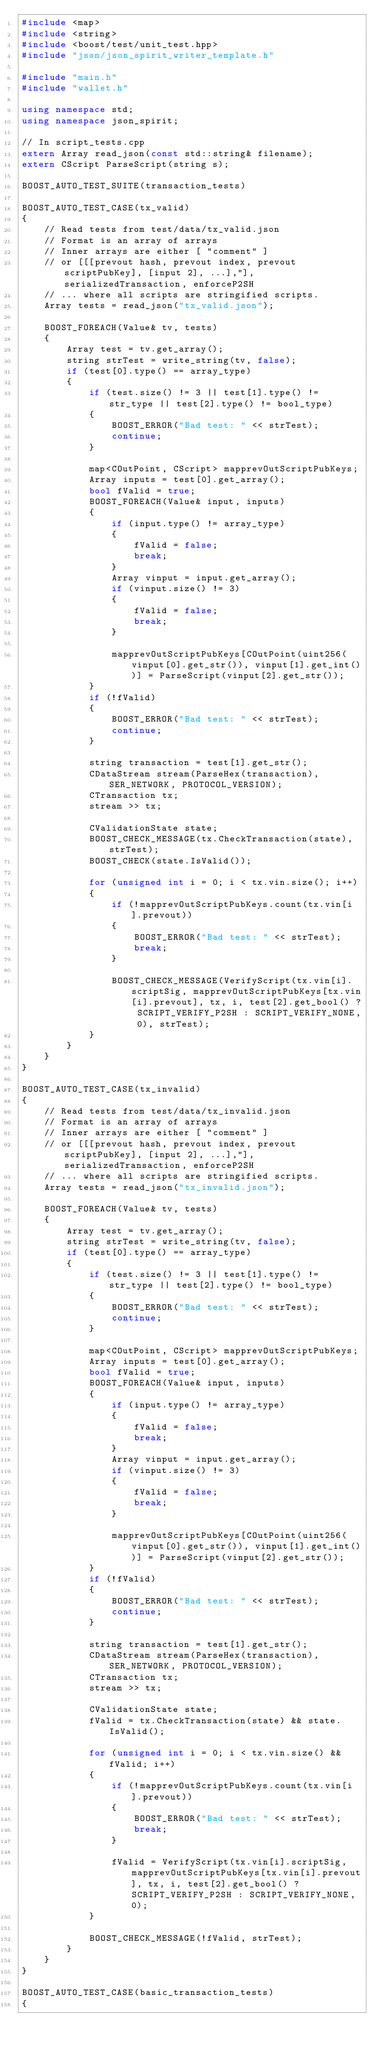<code> <loc_0><loc_0><loc_500><loc_500><_C++_>#include <map>
#include <string>
#include <boost/test/unit_test.hpp>
#include "json/json_spirit_writer_template.h"

#include "main.h"
#include "wallet.h"

using namespace std;
using namespace json_spirit;

// In script_tests.cpp
extern Array read_json(const std::string& filename);
extern CScript ParseScript(string s);

BOOST_AUTO_TEST_SUITE(transaction_tests)

BOOST_AUTO_TEST_CASE(tx_valid)
{
    // Read tests from test/data/tx_valid.json
    // Format is an array of arrays
    // Inner arrays are either [ "comment" ]
    // or [[[prevout hash, prevout index, prevout scriptPubKey], [input 2], ...],"], serializedTransaction, enforceP2SH
    // ... where all scripts are stringified scripts.
    Array tests = read_json("tx_valid.json");

    BOOST_FOREACH(Value& tv, tests)
    {
        Array test = tv.get_array();
        string strTest = write_string(tv, false);
        if (test[0].type() == array_type)
        {
            if (test.size() != 3 || test[1].type() != str_type || test[2].type() != bool_type)
            {
                BOOST_ERROR("Bad test: " << strTest);
                continue;
            }

            map<COutPoint, CScript> mapprevOutScriptPubKeys;
            Array inputs = test[0].get_array();
            bool fValid = true;
            BOOST_FOREACH(Value& input, inputs)
            {
                if (input.type() != array_type)
                {
                    fValid = false;
                    break;
                }
                Array vinput = input.get_array();
                if (vinput.size() != 3)
                {
                    fValid = false;
                    break;
                }

                mapprevOutScriptPubKeys[COutPoint(uint256(vinput[0].get_str()), vinput[1].get_int())] = ParseScript(vinput[2].get_str());
            }
            if (!fValid)
            {
                BOOST_ERROR("Bad test: " << strTest);
                continue;
            }

            string transaction = test[1].get_str();
            CDataStream stream(ParseHex(transaction), SER_NETWORK, PROTOCOL_VERSION);
            CTransaction tx;
            stream >> tx;

            CValidationState state;
            BOOST_CHECK_MESSAGE(tx.CheckTransaction(state), strTest);
            BOOST_CHECK(state.IsValid());

            for (unsigned int i = 0; i < tx.vin.size(); i++)
            {
                if (!mapprevOutScriptPubKeys.count(tx.vin[i].prevout))
                {
                    BOOST_ERROR("Bad test: " << strTest);
                    break;
                }

                BOOST_CHECK_MESSAGE(VerifyScript(tx.vin[i].scriptSig, mapprevOutScriptPubKeys[tx.vin[i].prevout], tx, i, test[2].get_bool() ? SCRIPT_VERIFY_P2SH : SCRIPT_VERIFY_NONE, 0), strTest);
            }
        }
    }
}

BOOST_AUTO_TEST_CASE(tx_invalid)
{
    // Read tests from test/data/tx_invalid.json
    // Format is an array of arrays
    // Inner arrays are either [ "comment" ]
    // or [[[prevout hash, prevout index, prevout scriptPubKey], [input 2], ...],"], serializedTransaction, enforceP2SH
    // ... where all scripts are stringified scripts.
    Array tests = read_json("tx_invalid.json");

    BOOST_FOREACH(Value& tv, tests)
    {
        Array test = tv.get_array();
        string strTest = write_string(tv, false);
        if (test[0].type() == array_type)
        {
            if (test.size() != 3 || test[1].type() != str_type || test[2].type() != bool_type)
            {
                BOOST_ERROR("Bad test: " << strTest);
                continue;
            }

            map<COutPoint, CScript> mapprevOutScriptPubKeys;
            Array inputs = test[0].get_array();
            bool fValid = true;
            BOOST_FOREACH(Value& input, inputs)
            {
                if (input.type() != array_type)
                {
                    fValid = false;
                    break;
                }
                Array vinput = input.get_array();
                if (vinput.size() != 3)
                {
                    fValid = false;
                    break;
                }

                mapprevOutScriptPubKeys[COutPoint(uint256(vinput[0].get_str()), vinput[1].get_int())] = ParseScript(vinput[2].get_str());
            }
            if (!fValid)
            {
                BOOST_ERROR("Bad test: " << strTest);
                continue;
            }

            string transaction = test[1].get_str();
            CDataStream stream(ParseHex(transaction), SER_NETWORK, PROTOCOL_VERSION);
            CTransaction tx;
            stream >> tx;

            CValidationState state;
            fValid = tx.CheckTransaction(state) && state.IsValid();

            for (unsigned int i = 0; i < tx.vin.size() && fValid; i++)
            {
                if (!mapprevOutScriptPubKeys.count(tx.vin[i].prevout))
                {
                    BOOST_ERROR("Bad test: " << strTest);
                    break;
                }

                fValid = VerifyScript(tx.vin[i].scriptSig, mapprevOutScriptPubKeys[tx.vin[i].prevout], tx, i, test[2].get_bool() ? SCRIPT_VERIFY_P2SH : SCRIPT_VERIFY_NONE, 0);
            }

            BOOST_CHECK_MESSAGE(!fValid, strTest);
        }
    }
}

BOOST_AUTO_TEST_CASE(basic_transaction_tests)
{</code> 